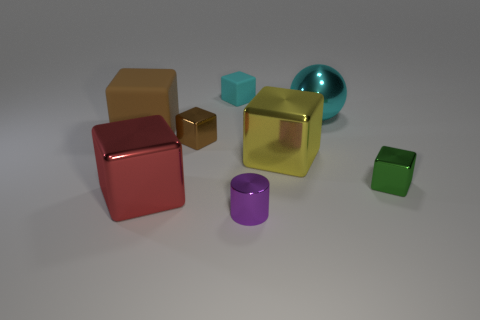Subtract all small brown blocks. How many blocks are left? 5 Add 2 spheres. How many objects exist? 10 Subtract all blue spheres. How many brown blocks are left? 2 Subtract all red cubes. How many cubes are left? 5 Add 5 large red objects. How many large red objects exist? 6 Subtract 0 purple cubes. How many objects are left? 8 Subtract all cubes. How many objects are left? 2 Subtract 5 cubes. How many cubes are left? 1 Subtract all red balls. Subtract all red cylinders. How many balls are left? 1 Subtract all green metal blocks. Subtract all tiny objects. How many objects are left? 3 